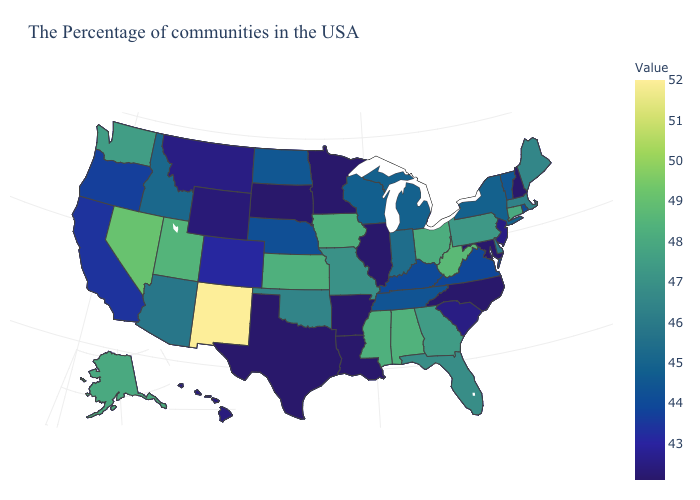Among the states that border Colorado , which have the lowest value?
Quick response, please. Wyoming. Does Georgia have a lower value than Massachusetts?
Answer briefly. No. Does Rhode Island have the lowest value in the Northeast?
Keep it brief. No. Is the legend a continuous bar?
Quick response, please. Yes. Does California have a higher value than Michigan?
Quick response, please. No. Does the map have missing data?
Write a very short answer. No. Does South Carolina have a higher value than Maine?
Short answer required. No. 